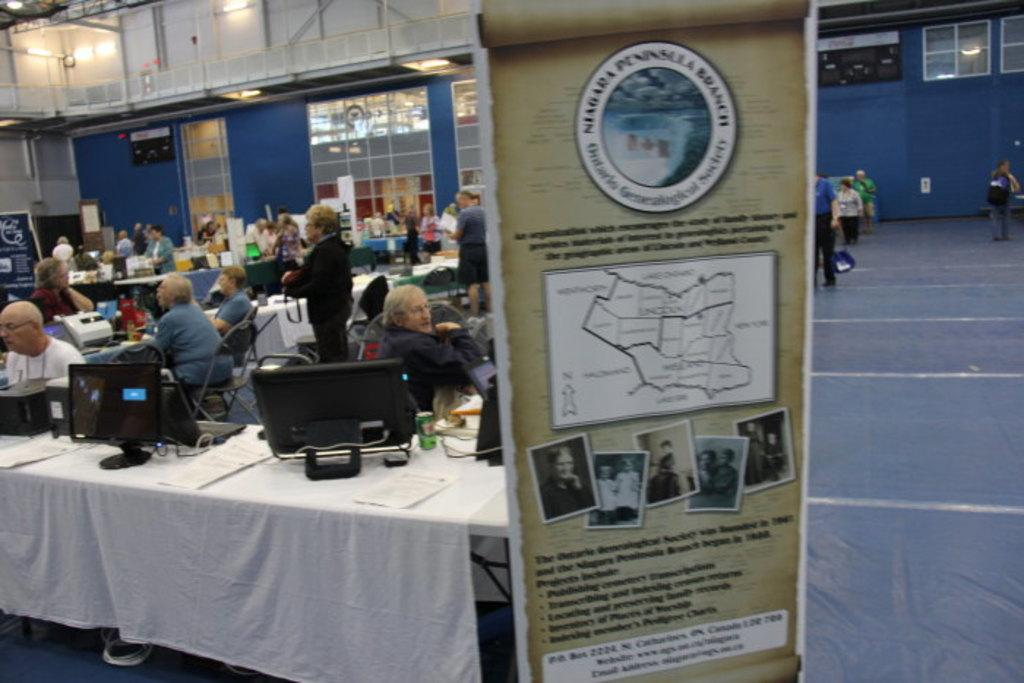<image>
Describe the image concisely. A vertical sign with a circle that reads Niagara Peninsula Branch. 